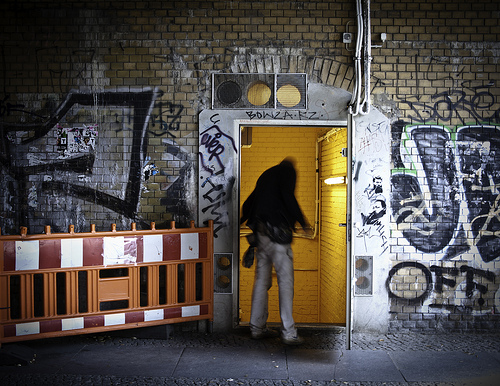Please provide the bounding box coordinate of the region this sentence describes: a wire grate covering a hole. The coordinates [0.69, 0.62, 0.75, 0.7] mark a wire grate over a small hole in a brick wall, likely serving as a protective measure against urban wildlife and litter. 